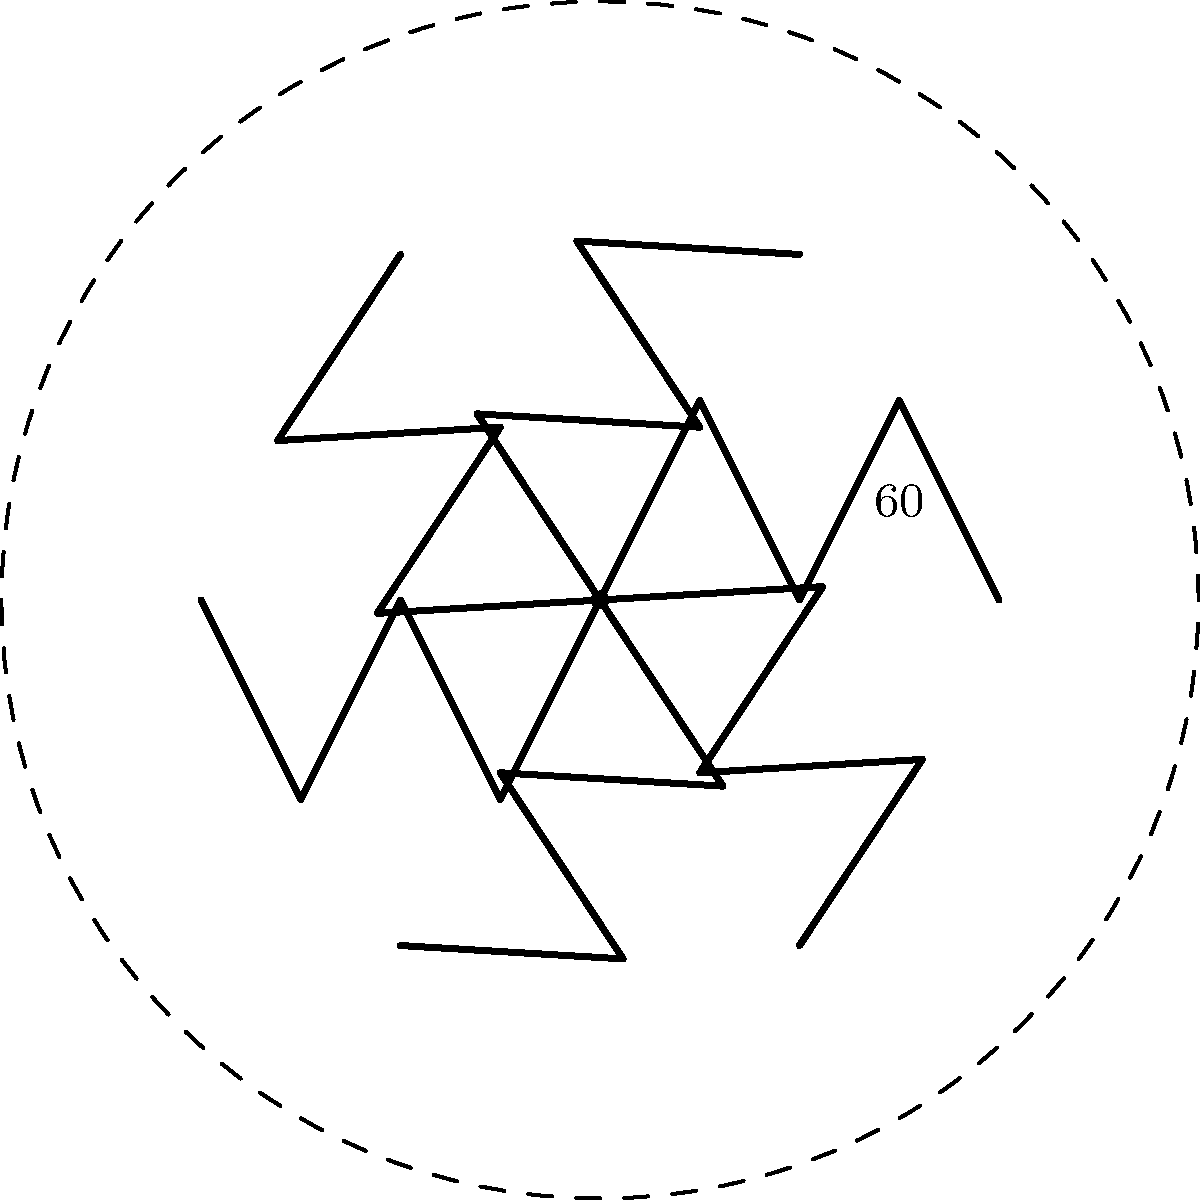For an upcoming gala, you want to create a symmetrical chandelier design on the ballroom ceiling. The design consists of a single chandelier arm rotated around a central point. If the chandelier pattern shown has $6$-fold rotational symmetry, what is the angle of rotation between each successive arm? How many rotations are needed to complete the full pattern? To solve this problem, let's break it down step-by-step:

1) First, we need to understand what $n$-fold rotational symmetry means. It indicates that the pattern can be rotated $n$ times around its center, and it will look the same after each rotation.

2) In this case, we have 6-fold rotational symmetry, which means the pattern repeats 6 times in a full 360° rotation.

3) To find the angle of rotation between each successive arm, we need to divide the full rotation (360°) by the number of repetitions (6):

   $\text{Angle of rotation} = \frac{360°}{6} = 60°$

4) This means that each chandelier arm is rotated 60° from the previous one to create the symmetrical pattern.

5) To determine how many rotations are needed to complete the full pattern, we need to consider that the first arm is already in place (0° rotation), and we rotate 5 more times to complete the pattern:

   $\text{Number of rotations} = 6 - 1 = 5$

Therefore, the angle of rotation between each successive arm is 60°, and 5 rotations are needed to complete the full pattern.
Answer: 60°; 5 rotations 